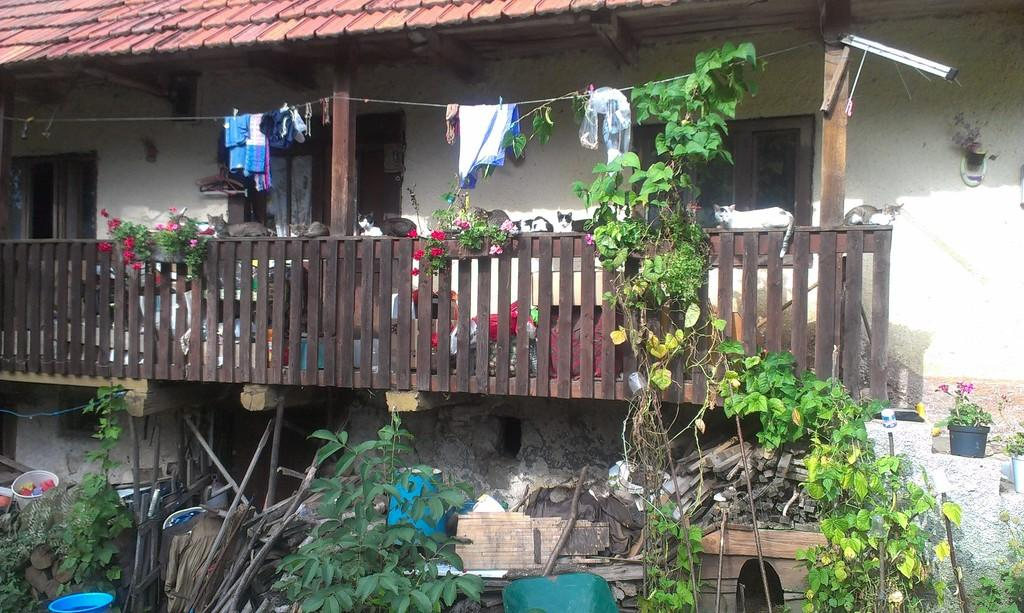What type of structure is visible in the image? There is a roof house in the image. Where is the balcony located in the image? The balcony is in the middle of the image. What type of vegetation is at the bottom of the image? There are plants at the bottom of the image. What is hanging at the top of the image? There are clothes at the top of the image. What type of table is visible in the image? There is no table present in the image. What type of dress is being worn by the person on the balcony? There is no person or dress visible in the image. 